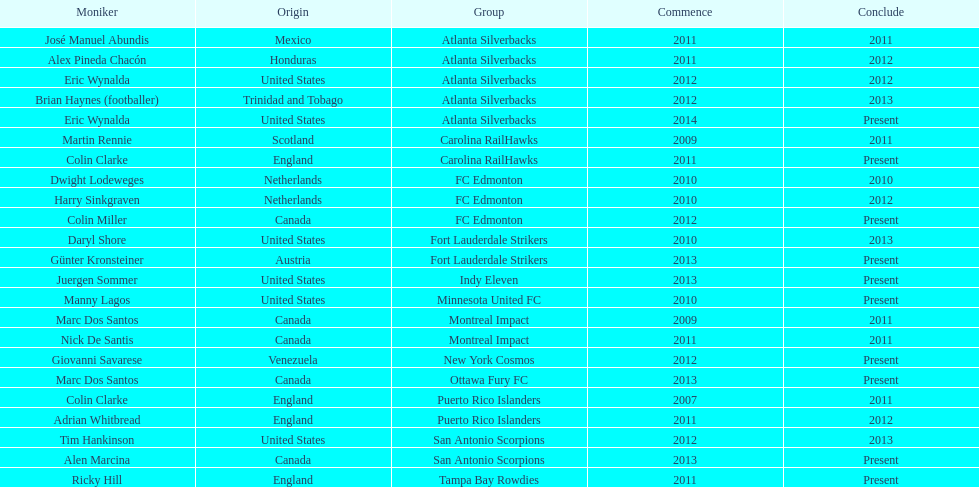How many coaches have coached from america? 6. 